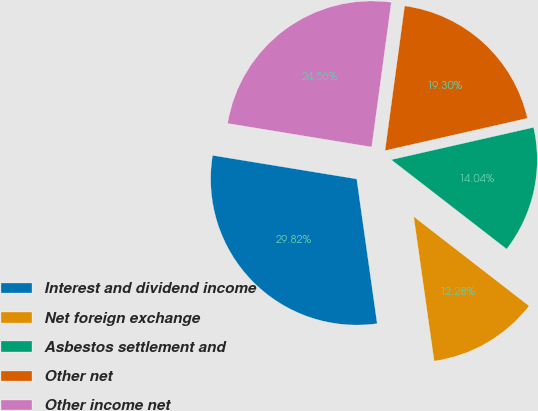Convert chart. <chart><loc_0><loc_0><loc_500><loc_500><pie_chart><fcel>Interest and dividend income<fcel>Net foreign exchange<fcel>Asbestos settlement and<fcel>Other net<fcel>Other income net<nl><fcel>29.82%<fcel>12.28%<fcel>14.04%<fcel>19.3%<fcel>24.56%<nl></chart> 